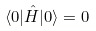Convert formula to latex. <formula><loc_0><loc_0><loc_500><loc_500>\langle 0 | \hat { H } | 0 \rangle = 0</formula> 